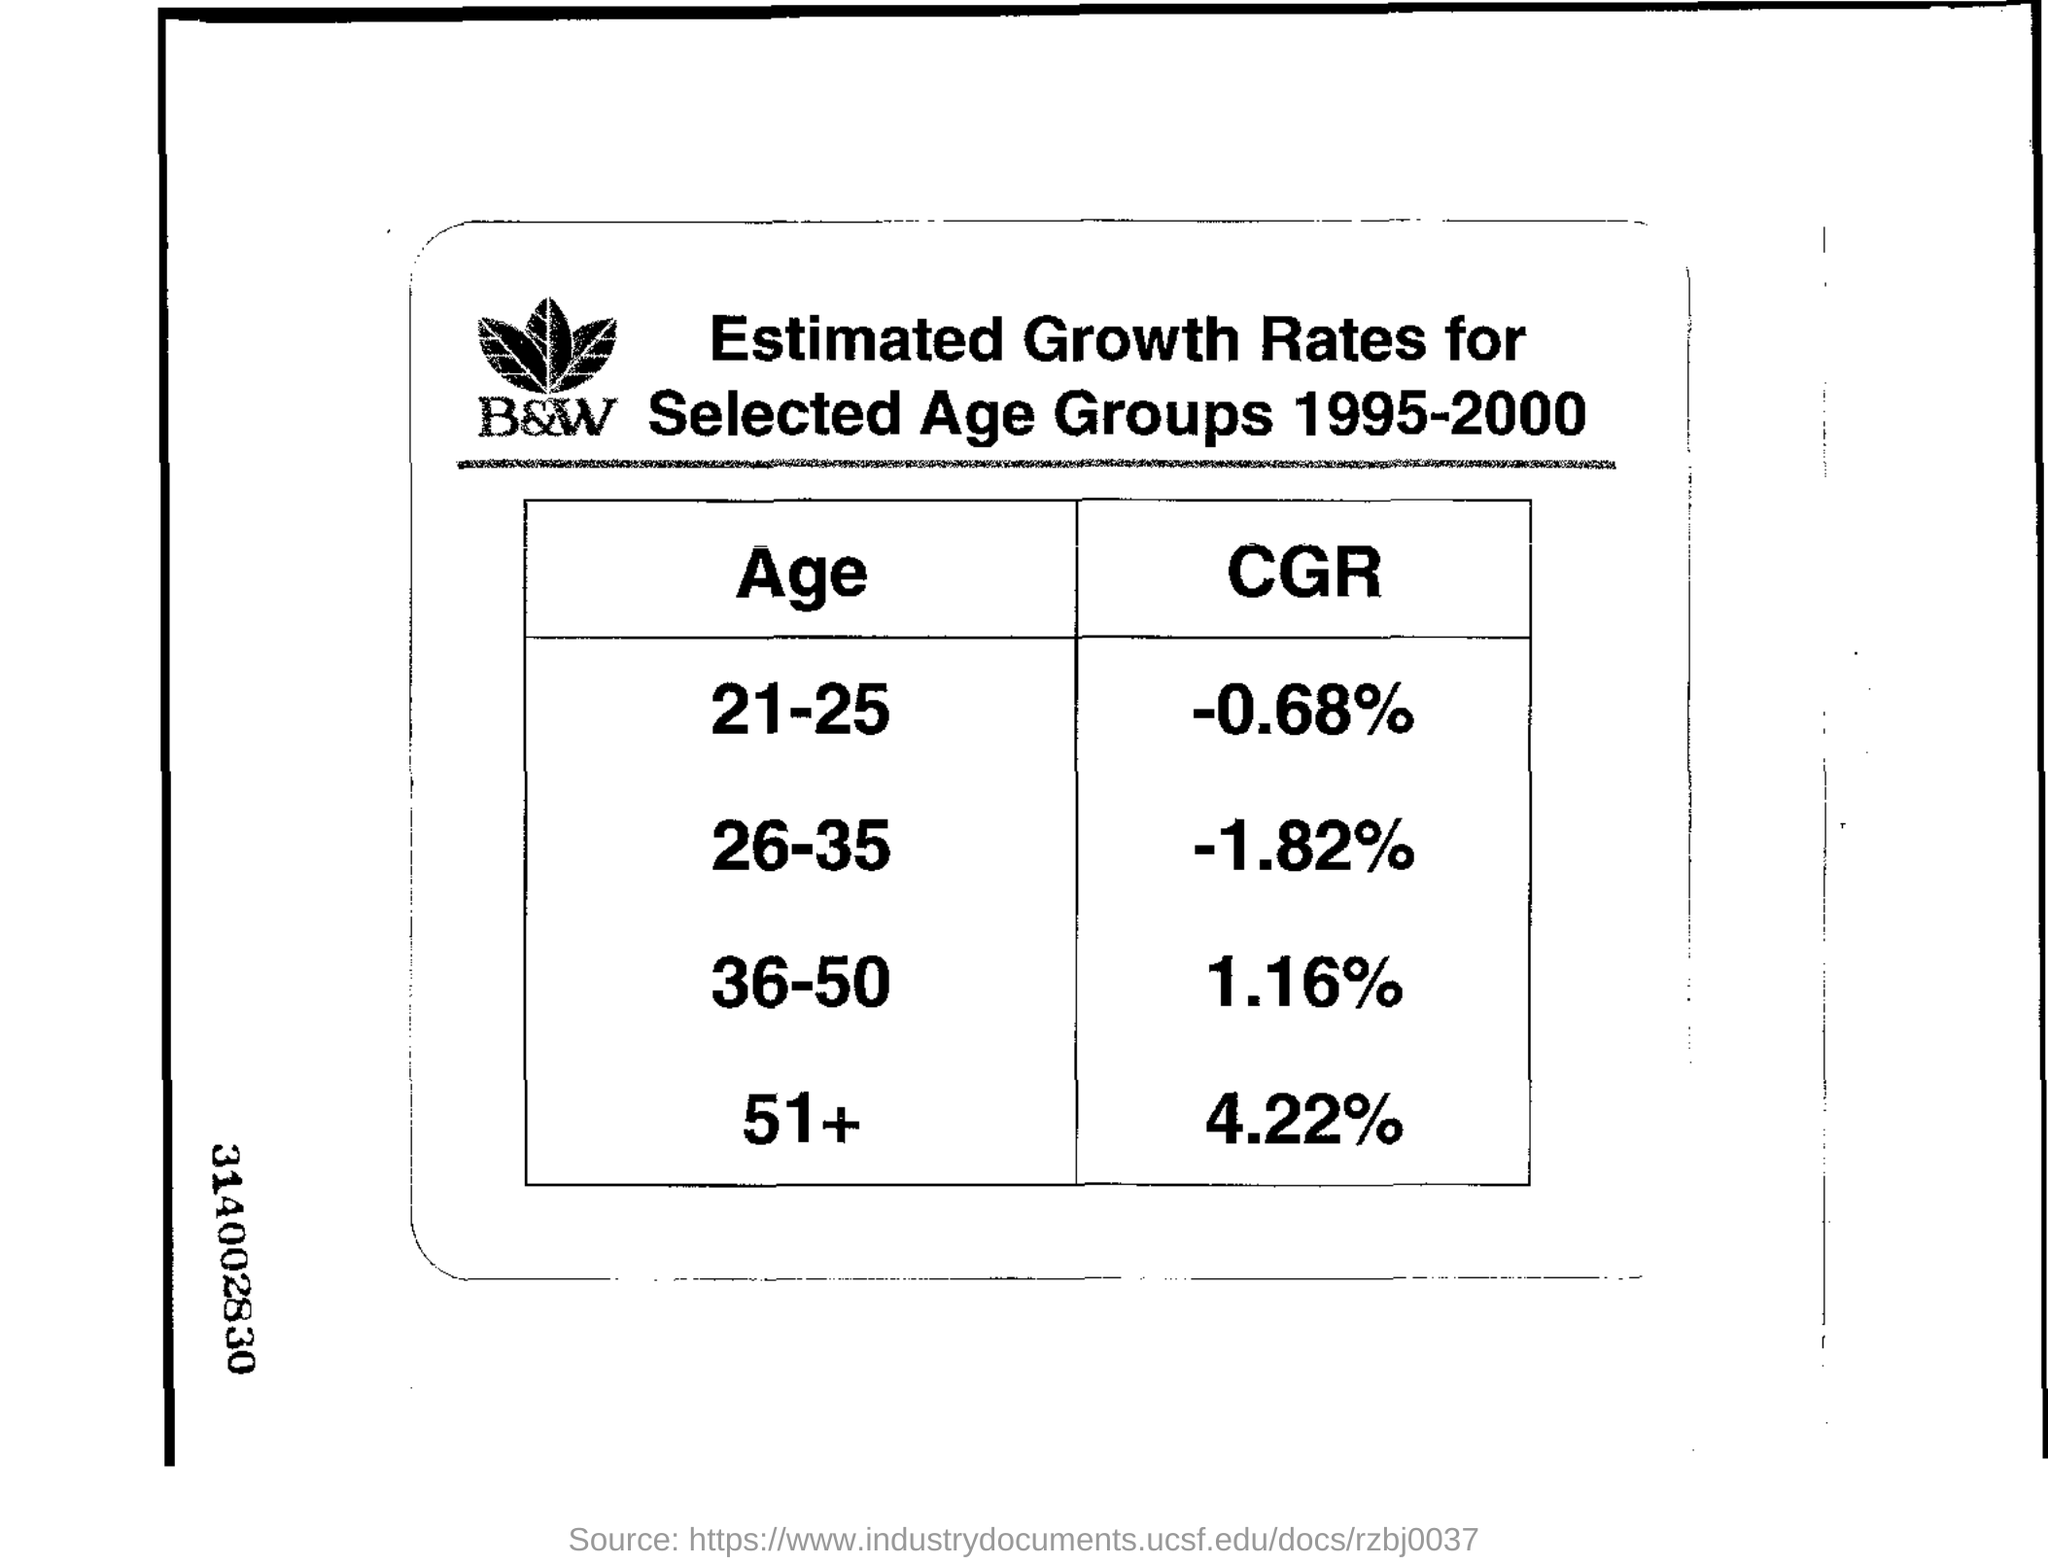What is the cgr for the age group 21-25?
Your answer should be compact. -0.68%. Which age group is having the highest estimated growth rate or cgr?
Ensure brevity in your answer.  51+. Which age group is having the lowest estimated growth rate or cgr?
Provide a succinct answer. 26-35. Between which years estimated growth rates have been taken?                          ?\
Offer a very short reply. 1995-2000. 